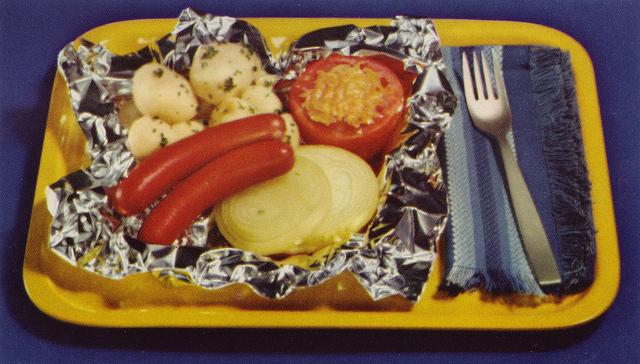What color is the napkins?
Give a very brief answer. Blue. How many sausages are on the tray?
Give a very brief answer. 2. Is the food on a tray?
Short answer required. Yes. What is the food inside of?
Short answer required. Foil. 